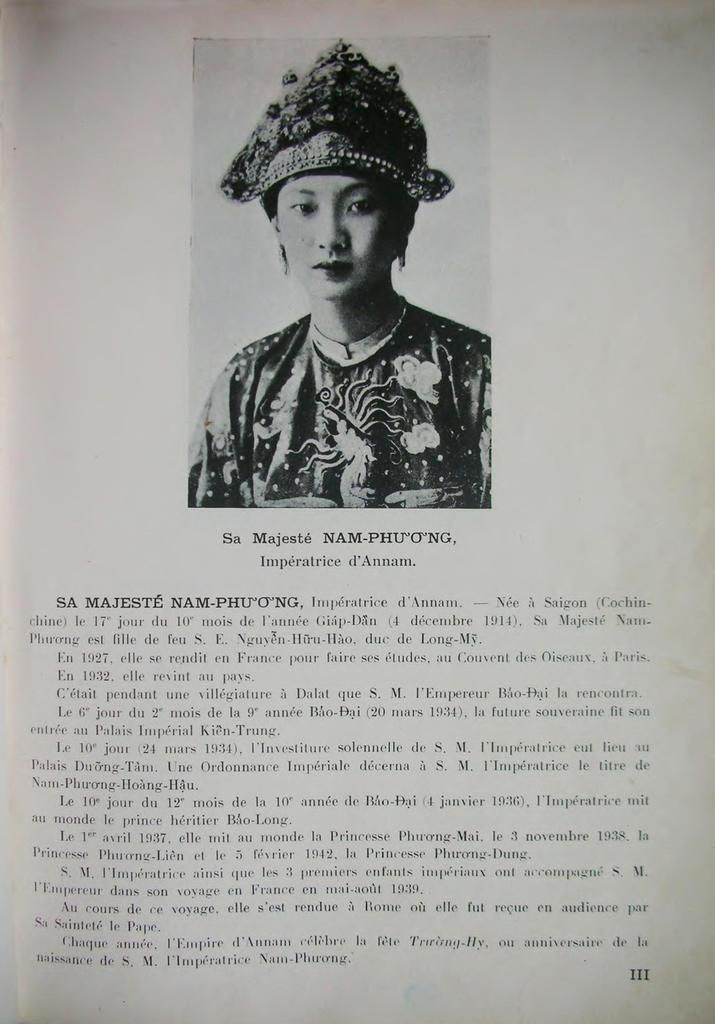What is present on the paper in the image? There is a woman depicted on the paper. Can you describe the woman on the paper? The provided facts do not give any details about the woman's appearance or actions. What type of organization is the woman associated with in the image? There is no information provided about any organization or affiliation related to the woman depicted on the paper. Is the woman holding any honey in the image? There is no mention of honey or any other objects in the image. How many babies is the woman holding in the image? There is no information provided about any babies or other people in the image. 